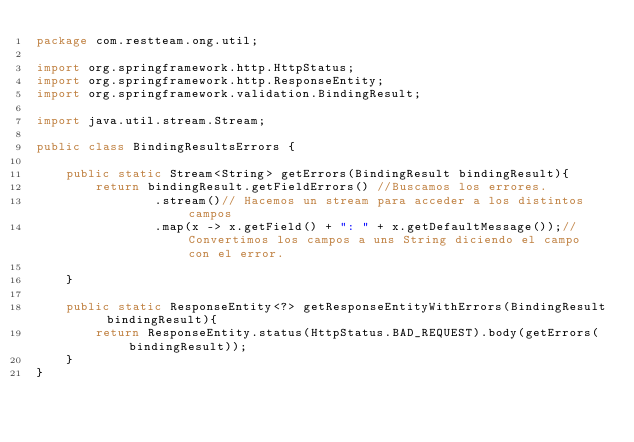Convert code to text. <code><loc_0><loc_0><loc_500><loc_500><_Java_>package com.restteam.ong.util;

import org.springframework.http.HttpStatus;
import org.springframework.http.ResponseEntity;
import org.springframework.validation.BindingResult;

import java.util.stream.Stream;

public class BindingResultsErrors {

    public static Stream<String> getErrors(BindingResult bindingResult){
        return bindingResult.getFieldErrors() //Buscamos los errores.
                .stream()// Hacemos un stream para acceder a los distintos campos
                .map(x -> x.getField() + ": " + x.getDefaultMessage());// Convertimos los campos a uns String diciendo el campo con el error.

    }

    public static ResponseEntity<?> getResponseEntityWithErrors(BindingResult bindingResult){
        return ResponseEntity.status(HttpStatus.BAD_REQUEST).body(getErrors(bindingResult));
    }
}
</code> 